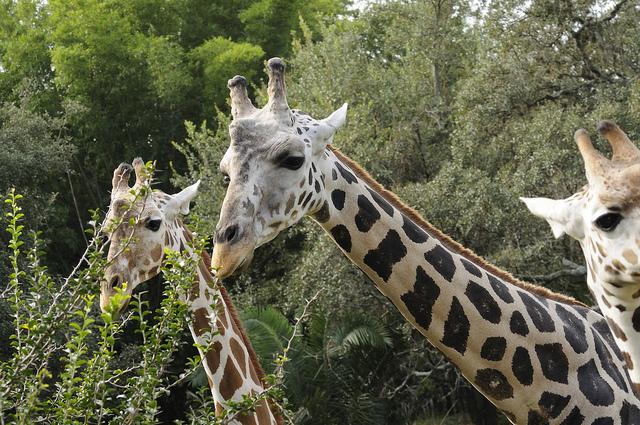Do these giraffes live in a zoo?
Be succinct. Yes. Which giraffe is the tallest?
Short answer required. Middle. How many horns do the giraffe have?
Concise answer only. 2. 